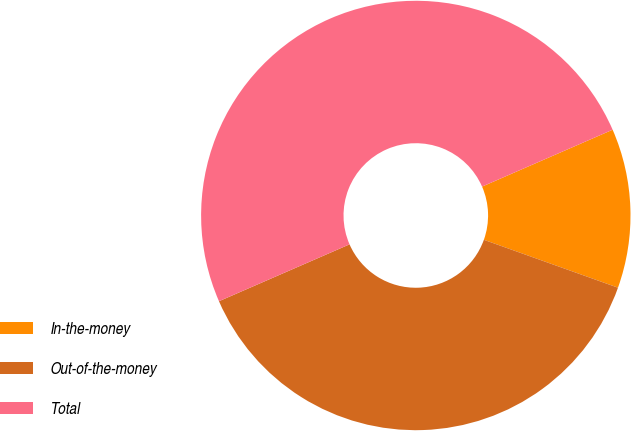Convert chart. <chart><loc_0><loc_0><loc_500><loc_500><pie_chart><fcel>In-the-money<fcel>Out-of-the-money<fcel>Total<nl><fcel>12.0%<fcel>38.0%<fcel>50.0%<nl></chart> 